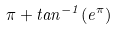<formula> <loc_0><loc_0><loc_500><loc_500>\pi + t a n ^ { - 1 } ( e ^ { \pi } )</formula> 